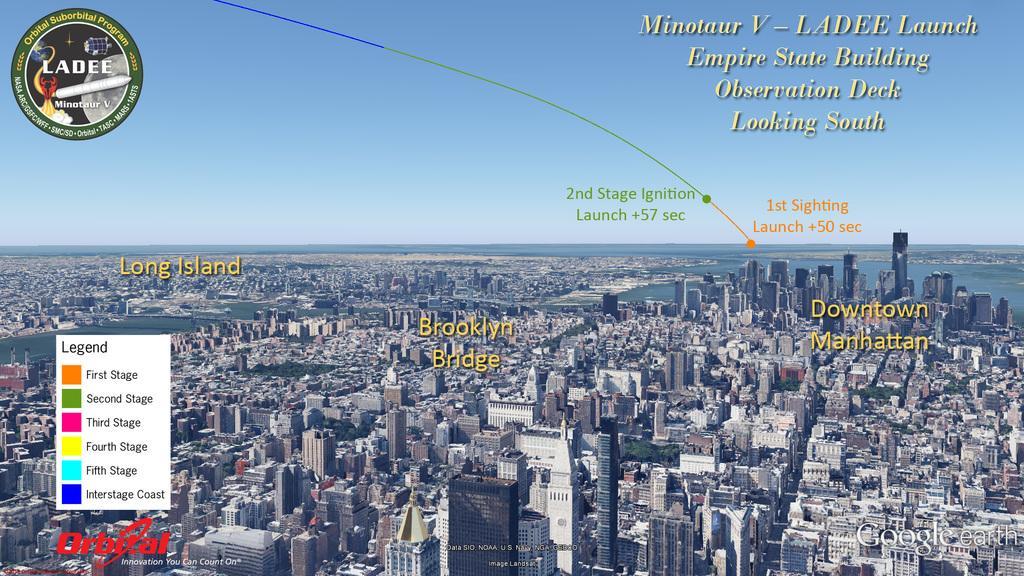In one or two sentences, can you explain what this image depicts? This is the top view of the city, in this image there are buildings and water and there are some text and logos on the image. 